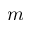Convert formula to latex. <formula><loc_0><loc_0><loc_500><loc_500>m</formula> 